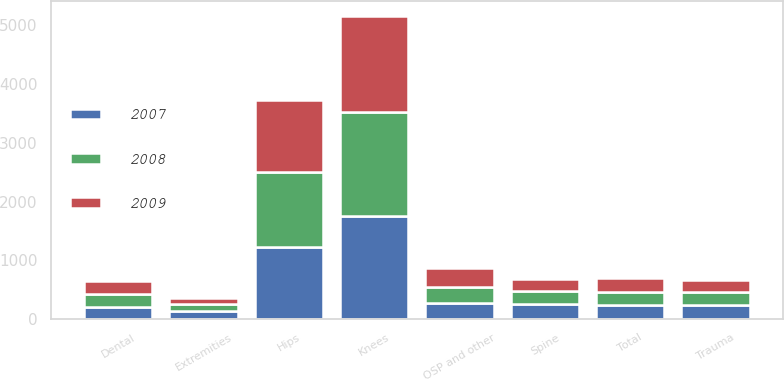<chart> <loc_0><loc_0><loc_500><loc_500><stacked_bar_chart><ecel><fcel>Knees<fcel>Hips<fcel>Extremities<fcel>Total<fcel>Dental<fcel>Trauma<fcel>Spine<fcel>OSP and other<nl><fcel>2007<fcel>1760.6<fcel>1228.5<fcel>135.6<fcel>234.8<fcel>204.7<fcel>234.8<fcel>253.6<fcel>277.6<nl><fcel>2008<fcel>1763.1<fcel>1279.4<fcel>121<fcel>234.8<fcel>227.5<fcel>222.3<fcel>229.7<fcel>278.1<nl><fcel>2009<fcel>1634.6<fcel>1221.4<fcel>104<fcel>234.8<fcel>221<fcel>205.8<fcel>197<fcel>313.7<nl></chart> 